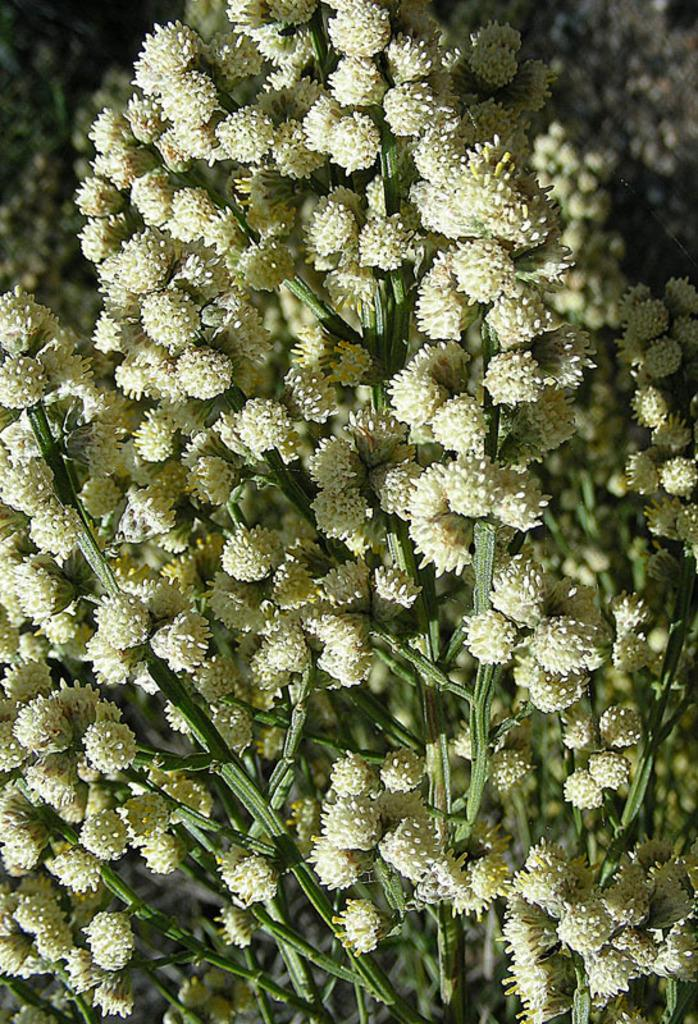What color are the flowers in the image? The flowers in the image are white in color. What color are the stems of the flowers in the image? The stems of the flowers in the image are green in color. What type of hat is being worn by the flowers in the image? There are no hats present in the image, as it features flowers and their stems. Can you confirm the existence of a process that the flowers are undergoing in the image? There is no process mentioned or depicted in the image; it simply shows white flowers with green stems. 